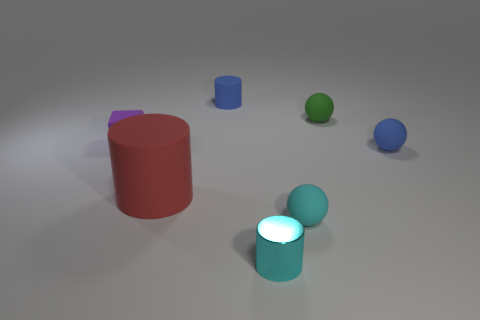Is the size of the blue object that is behind the tiny blue sphere the same as the cylinder on the left side of the blue matte cylinder?
Give a very brief answer. No. What color is the small rubber ball in front of the blue matte object that is to the right of the cyan metal cylinder that is on the right side of the blue matte cylinder?
Provide a succinct answer. Cyan. Is there a small purple matte thing that has the same shape as the small cyan matte object?
Give a very brief answer. No. Is the number of small matte blocks in front of the big rubber cylinder the same as the number of small purple rubber blocks right of the shiny object?
Make the answer very short. Yes. There is a tiny blue object behind the tiny blue rubber ball; is its shape the same as the big object?
Keep it short and to the point. Yes. Does the small green object have the same shape as the tiny cyan metal thing?
Keep it short and to the point. No. How many matte things are either yellow blocks or cyan spheres?
Ensure brevity in your answer.  1. What is the material of the small object that is the same color as the small metallic cylinder?
Provide a short and direct response. Rubber. Do the cyan cylinder and the green matte sphere have the same size?
Make the answer very short. Yes. What number of objects are either large cylinders or things in front of the tiny green object?
Keep it short and to the point. 5. 